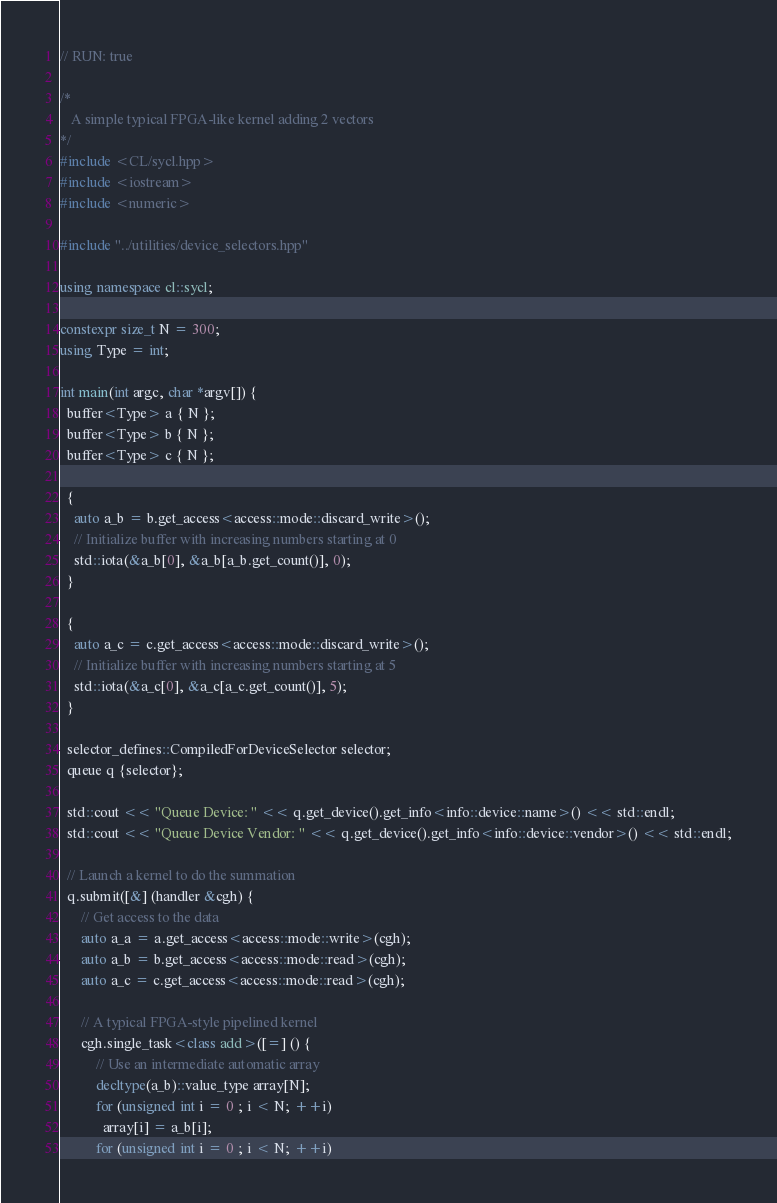Convert code to text. <code><loc_0><loc_0><loc_500><loc_500><_C++_>// RUN: true

/*
   A simple typical FPGA-like kernel adding 2 vectors
*/
#include <CL/sycl.hpp>
#include <iostream>
#include <numeric>

#include "../utilities/device_selectors.hpp"

using namespace cl::sycl;

constexpr size_t N = 300;
using Type = int;

int main(int argc, char *argv[]) {
  buffer<Type> a { N };
  buffer<Type> b { N };
  buffer<Type> c { N };

  {
    auto a_b = b.get_access<access::mode::discard_write>();
    // Initialize buffer with increasing numbers starting at 0
    std::iota(&a_b[0], &a_b[a_b.get_count()], 0);
  }

  {
    auto a_c = c.get_access<access::mode::discard_write>();
    // Initialize buffer with increasing numbers starting at 5
    std::iota(&a_c[0], &a_c[a_c.get_count()], 5);
  }

  selector_defines::CompiledForDeviceSelector selector;
  queue q {selector};

  std::cout << "Queue Device: " << q.get_device().get_info<info::device::name>() << std::endl;
  std::cout << "Queue Device Vendor: " << q.get_device().get_info<info::device::vendor>() << std::endl;

  // Launch a kernel to do the summation
  q.submit([&] (handler &cgh) {
      // Get access to the data
      auto a_a = a.get_access<access::mode::write>(cgh);
      auto a_b = b.get_access<access::mode::read>(cgh);
      auto a_c = c.get_access<access::mode::read>(cgh);

      // A typical FPGA-style pipelined kernel
      cgh.single_task<class add>([=] () {
          // Use an intermediate automatic array
          decltype(a_b)::value_type array[N];
          for (unsigned int i = 0 ; i < N; ++i)
            array[i] = a_b[i];
          for (unsigned int i = 0 ; i < N; ++i)</code> 